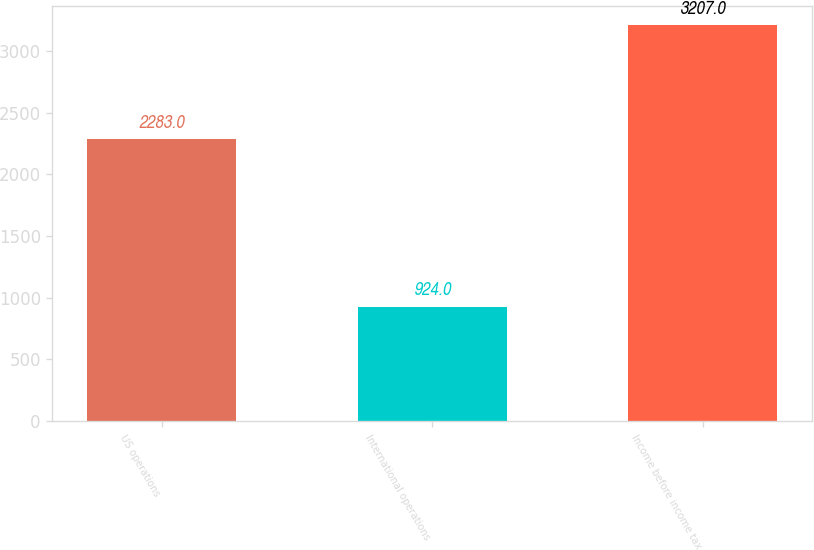Convert chart to OTSL. <chart><loc_0><loc_0><loc_500><loc_500><bar_chart><fcel>US operations<fcel>International operations<fcel>Income before income tax<nl><fcel>2283<fcel>924<fcel>3207<nl></chart> 